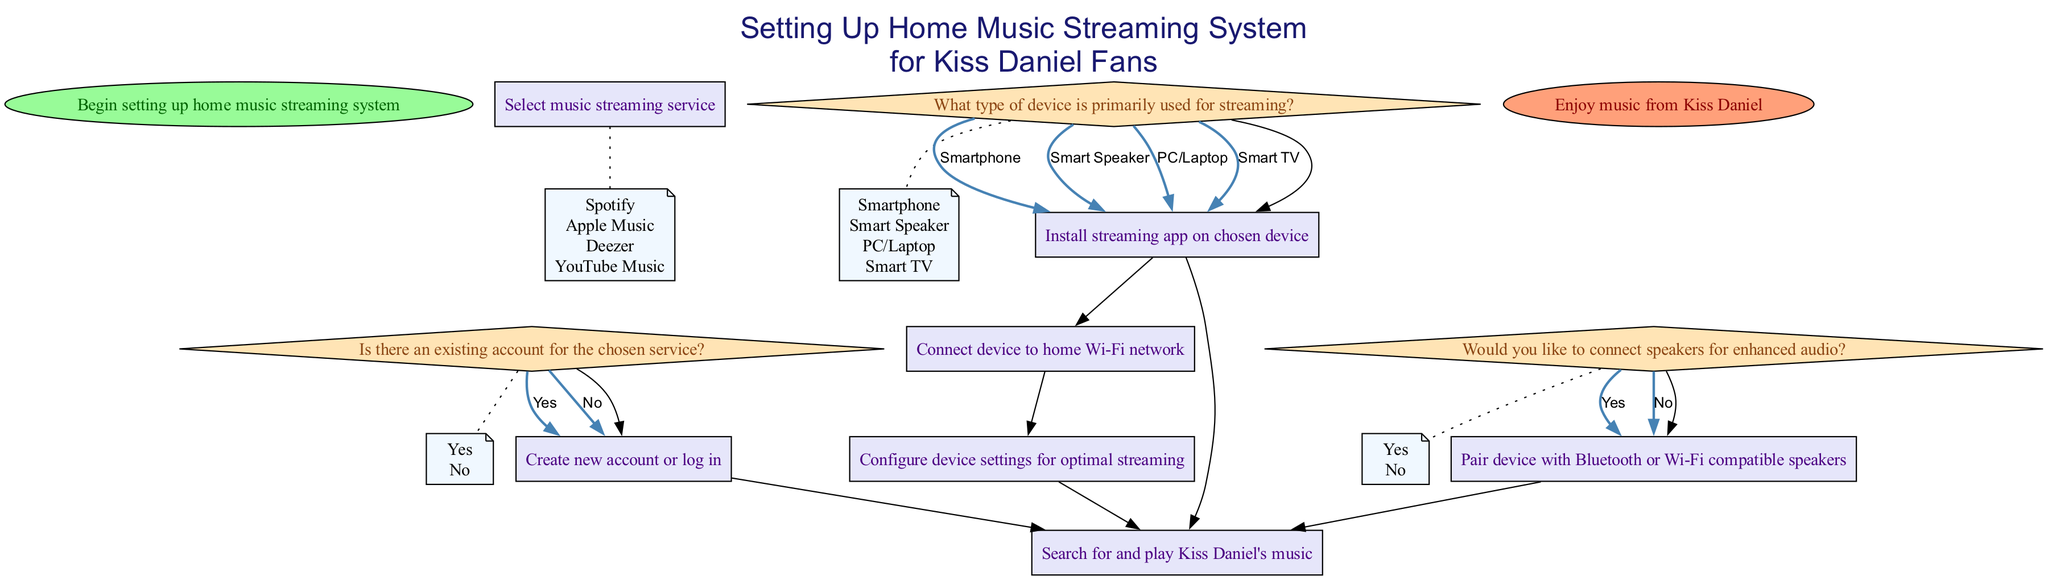What is the first step in the diagram? The first step in the diagram is to "Begin setting up home music streaming system," which is represented as the Start node.
Answer: Begin setting up home music streaming system How many music streaming services can be selected? The diagram presents four options for music streaming services listed in the Process node, "Select music streaming service."
Answer: Four What do you do if there is an existing account for the chosen service? If there is an existing account, the next step according to the Decision node is to "Log in to existing account," which leads to the Process node for login.
Answer: Log in to existing account What type of devices can be used for streaming according to the diagram? The Decision node provides four options for the type of device: Smartphone, Smart Speaker, PC/Laptop, and Smart TV, which indicates the possible devices for streaming.
Answer: Smartphone, Smart Speaker, PC/Laptop, Smart TV If you want to connect speakers, what step comes after making the decision? If the decision is to connect speakers (Yes), the next step is to "Pair device with Bluetooth or Wi-Fi compatible speakers," clearly stated in the Process node following the Decision node about connecting speakers.
Answer: Pair device with Bluetooth or Wi-Fi compatible speakers What is the final step mentioned in the diagram? The final step in the diagram is captured in the End node, which states, "Enjoy music from Kiss Daniel," marking the completion of the setup process.
Answer: Enjoy music from Kiss Daniel What must be adjusted in the device settings for optimal streaming? According to the details provided in the Process node, the device settings for optimal streaming should include adjustments for audio quality, notifications, and offline mode, specific to the chosen device.
Answer: Audio quality, notifications, and offline mode How do you begin if you do not have an existing account? If there is no existing account, the next step is to "Create new account" as indicated in the conditions of the Process node under the Decision node.
Answer: Create new account 